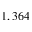<formula> <loc_0><loc_0><loc_500><loc_500>1 , 3 6 4</formula> 